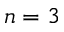Convert formula to latex. <formula><loc_0><loc_0><loc_500><loc_500>n = 3</formula> 